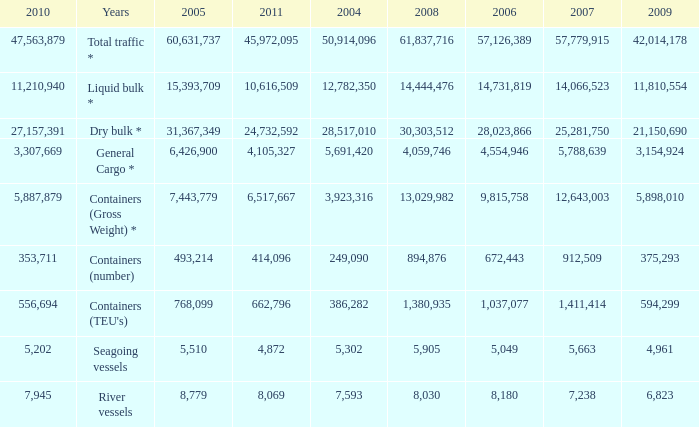I'm looking to parse the entire table for insights. Could you assist me with that? {'header': ['2010', 'Years', '2005', '2011', '2004', '2008', '2006', '2007', '2009'], 'rows': [['47,563,879', 'Total traffic *', '60,631,737', '45,972,095', '50,914,096', '61,837,716', '57,126,389', '57,779,915', '42,014,178'], ['11,210,940', 'Liquid bulk *', '15,393,709', '10,616,509', '12,782,350', '14,444,476', '14,731,819', '14,066,523', '11,810,554'], ['27,157,391', 'Dry bulk *', '31,367,349', '24,732,592', '28,517,010', '30,303,512', '28,023,866', '25,281,750', '21,150,690'], ['3,307,669', 'General Cargo *', '6,426,900', '4,105,327', '5,691,420', '4,059,746', '4,554,946', '5,788,639', '3,154,924'], ['5,887,879', 'Containers (Gross Weight) *', '7,443,779', '6,517,667', '3,923,316', '13,029,982', '9,815,758', '12,643,003', '5,898,010'], ['353,711', 'Containers (number)', '493,214', '414,096', '249,090', '894,876', '672,443', '912,509', '375,293'], ['556,694', "Containers (TEU's)", '768,099', '662,796', '386,282', '1,380,935', '1,037,077', '1,411,414', '594,299'], ['5,202', 'Seagoing vessels', '5,510', '4,872', '5,302', '5,905', '5,049', '5,663', '4,961'], ['7,945', 'River vessels', '8,779', '8,069', '7,593', '8,030', '8,180', '7,238', '6,823']]} What was the average value in 2005 when 2008 is 61,837,716, and a 2006 is more than 57,126,389? None. 